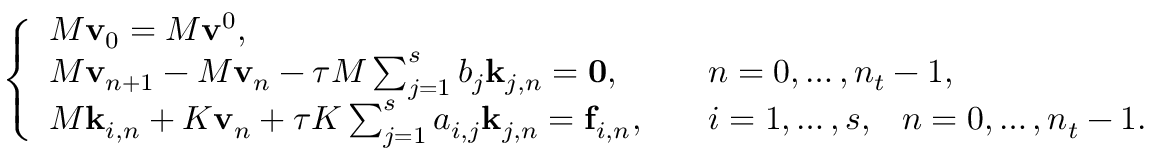<formula> <loc_0><loc_0><loc_500><loc_500>\left \{ \begin{array} { l l } { M v _ { 0 } = M v ^ { 0 } , } \\ { M v _ { n + 1 } - M v _ { n } - \tau M \sum _ { j = 1 } ^ { s } b _ { j } k _ { j , n } = 0 , } & { \quad n = 0 , \dots , n _ { t } - 1 , } \\ { M k _ { i , n } + K v _ { n } + \tau K \sum _ { j = 1 } ^ { s } a _ { i , j } k _ { j , n } = f _ { i , n } , } & { \quad i = 1 , \dots , s , \, n = 0 , \dots , n _ { t } - 1 . } \end{array}</formula> 